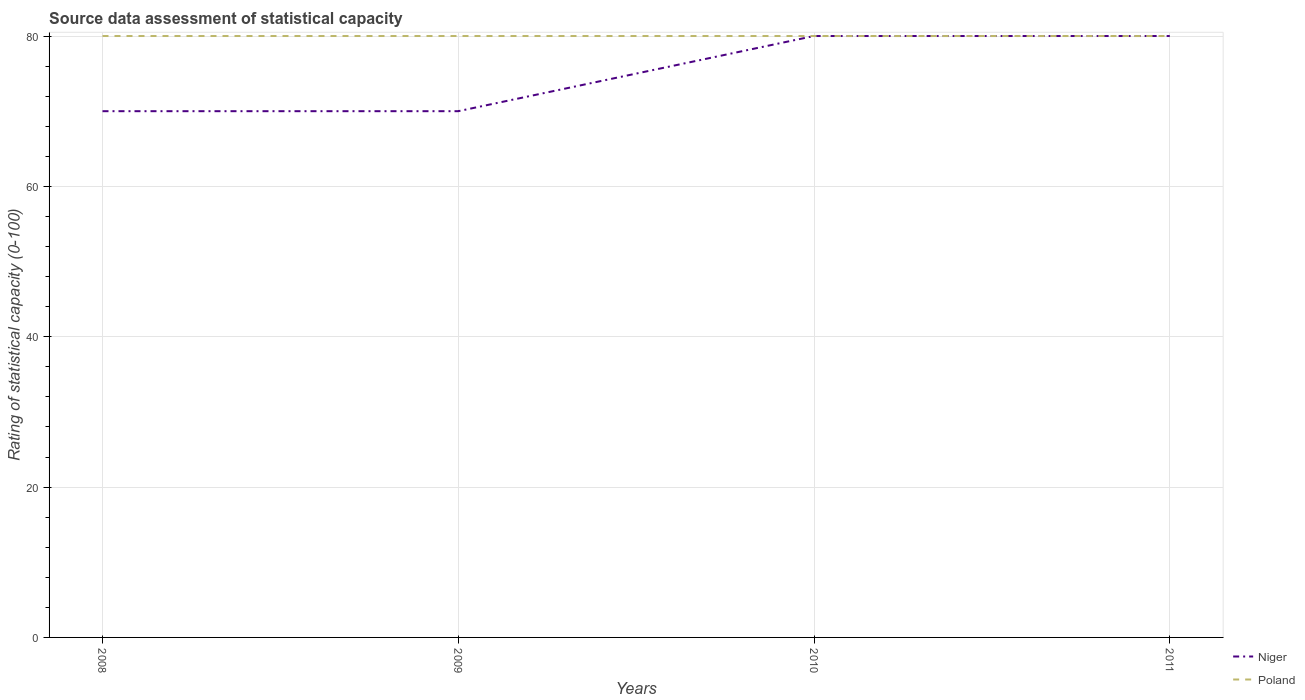Across all years, what is the maximum rating of statistical capacity in Poland?
Make the answer very short. 80. In which year was the rating of statistical capacity in Niger maximum?
Your answer should be very brief. 2008. What is the difference between the highest and the second highest rating of statistical capacity in Poland?
Offer a terse response. 0. What is the difference between the highest and the lowest rating of statistical capacity in Niger?
Provide a short and direct response. 2. Is the rating of statistical capacity in Poland strictly greater than the rating of statistical capacity in Niger over the years?
Your answer should be compact. No. How many lines are there?
Make the answer very short. 2. What is the difference between two consecutive major ticks on the Y-axis?
Offer a terse response. 20. How many legend labels are there?
Offer a terse response. 2. How are the legend labels stacked?
Make the answer very short. Vertical. What is the title of the graph?
Your answer should be compact. Source data assessment of statistical capacity. Does "Tunisia" appear as one of the legend labels in the graph?
Your response must be concise. No. What is the label or title of the Y-axis?
Provide a short and direct response. Rating of statistical capacity (0-100). What is the Rating of statistical capacity (0-100) in Niger in 2008?
Ensure brevity in your answer.  70. What is the Rating of statistical capacity (0-100) in Poland in 2008?
Provide a succinct answer. 80. What is the Rating of statistical capacity (0-100) of Niger in 2009?
Give a very brief answer. 70. What is the Rating of statistical capacity (0-100) of Niger in 2010?
Provide a short and direct response. 80. What is the Rating of statistical capacity (0-100) of Niger in 2011?
Provide a succinct answer. 80. Across all years, what is the maximum Rating of statistical capacity (0-100) in Niger?
Make the answer very short. 80. Across all years, what is the minimum Rating of statistical capacity (0-100) of Poland?
Offer a very short reply. 80. What is the total Rating of statistical capacity (0-100) in Niger in the graph?
Offer a very short reply. 300. What is the total Rating of statistical capacity (0-100) of Poland in the graph?
Offer a terse response. 320. What is the difference between the Rating of statistical capacity (0-100) of Niger in 2008 and that in 2009?
Your answer should be very brief. 0. What is the difference between the Rating of statistical capacity (0-100) of Poland in 2008 and that in 2009?
Make the answer very short. 0. What is the difference between the Rating of statistical capacity (0-100) in Niger in 2008 and that in 2010?
Provide a short and direct response. -10. What is the difference between the Rating of statistical capacity (0-100) of Niger in 2009 and that in 2010?
Your response must be concise. -10. What is the difference between the Rating of statistical capacity (0-100) in Poland in 2010 and that in 2011?
Your answer should be compact. 0. What is the difference between the Rating of statistical capacity (0-100) of Niger in 2008 and the Rating of statistical capacity (0-100) of Poland in 2009?
Ensure brevity in your answer.  -10. What is the difference between the Rating of statistical capacity (0-100) of Niger in 2008 and the Rating of statistical capacity (0-100) of Poland in 2011?
Provide a short and direct response. -10. What is the difference between the Rating of statistical capacity (0-100) of Niger in 2009 and the Rating of statistical capacity (0-100) of Poland in 2010?
Offer a terse response. -10. What is the difference between the Rating of statistical capacity (0-100) of Niger in 2010 and the Rating of statistical capacity (0-100) of Poland in 2011?
Your answer should be very brief. 0. What is the average Rating of statistical capacity (0-100) of Niger per year?
Ensure brevity in your answer.  75. What is the average Rating of statistical capacity (0-100) of Poland per year?
Your response must be concise. 80. In the year 2008, what is the difference between the Rating of statistical capacity (0-100) in Niger and Rating of statistical capacity (0-100) in Poland?
Offer a very short reply. -10. In the year 2009, what is the difference between the Rating of statistical capacity (0-100) in Niger and Rating of statistical capacity (0-100) in Poland?
Offer a very short reply. -10. What is the ratio of the Rating of statistical capacity (0-100) in Poland in 2008 to that in 2009?
Give a very brief answer. 1. What is the ratio of the Rating of statistical capacity (0-100) in Niger in 2009 to that in 2010?
Give a very brief answer. 0.88. What is the ratio of the Rating of statistical capacity (0-100) of Poland in 2009 to that in 2010?
Give a very brief answer. 1. What is the ratio of the Rating of statistical capacity (0-100) of Poland in 2010 to that in 2011?
Your answer should be compact. 1. 